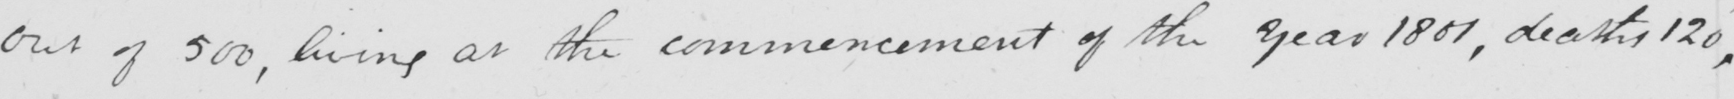Can you tell me what this handwritten text says? out of 500 , living at the commencement of the year 1801 , deaths 120 , 